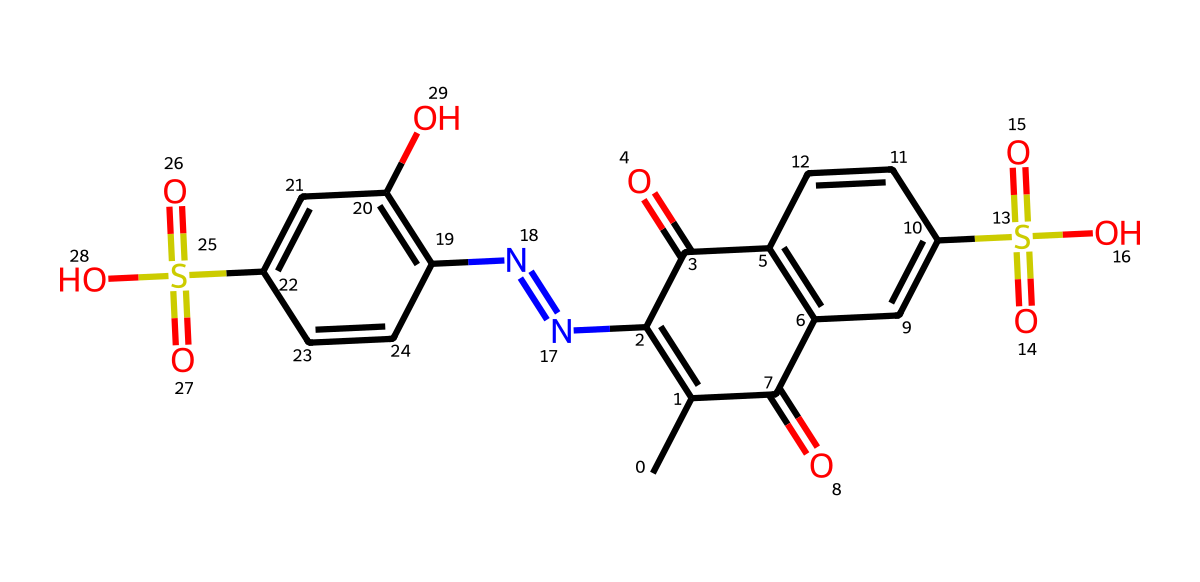What is the total number of carbon atoms in this chemical structure? Count the carbon (C) symbols in the SMILES notation, which indicate carbon atoms. Upon inspection, there are 15 carbon atoms in total.
Answer: fifteen How many nitrogen atoms are present in this molecule? Look for the nitrogen (N) symbols in the SMILES representation. There are 2 nitrogen atoms in the structure.
Answer: two What kind of functional groups are indicated by the presence of the "S(=O)(=O)O" portion? The "S(=O)(=O)" indicates a sulfonyl group, and the "O" represents a hydroxyl group, together forming sulfonic acid groups present in the molecule.
Answer: sulfonic acid What is the highest ring number present in the chemical structure? By analyzing the connections in the SMILES, the ring numbers indicate how many rings there are; here, we find the highest number is three, indicating this molecule has three interconnected rings.
Answer: three Which part of this chemical suggests it is used for coloring? The presence of multiple aromatic rings (evidenced by the alternating double bonds and attached groups) indicates strong coloring properties, typical for dyes and pigments.
Answer: aromatic rings How many hydrogen atoms are implied in this molecule? Based on the structure and the tetravalent nature of carbon atoms, we can deduce that the required hydrogen atoms to saturate the carbon rings totals 10.
Answer: ten 